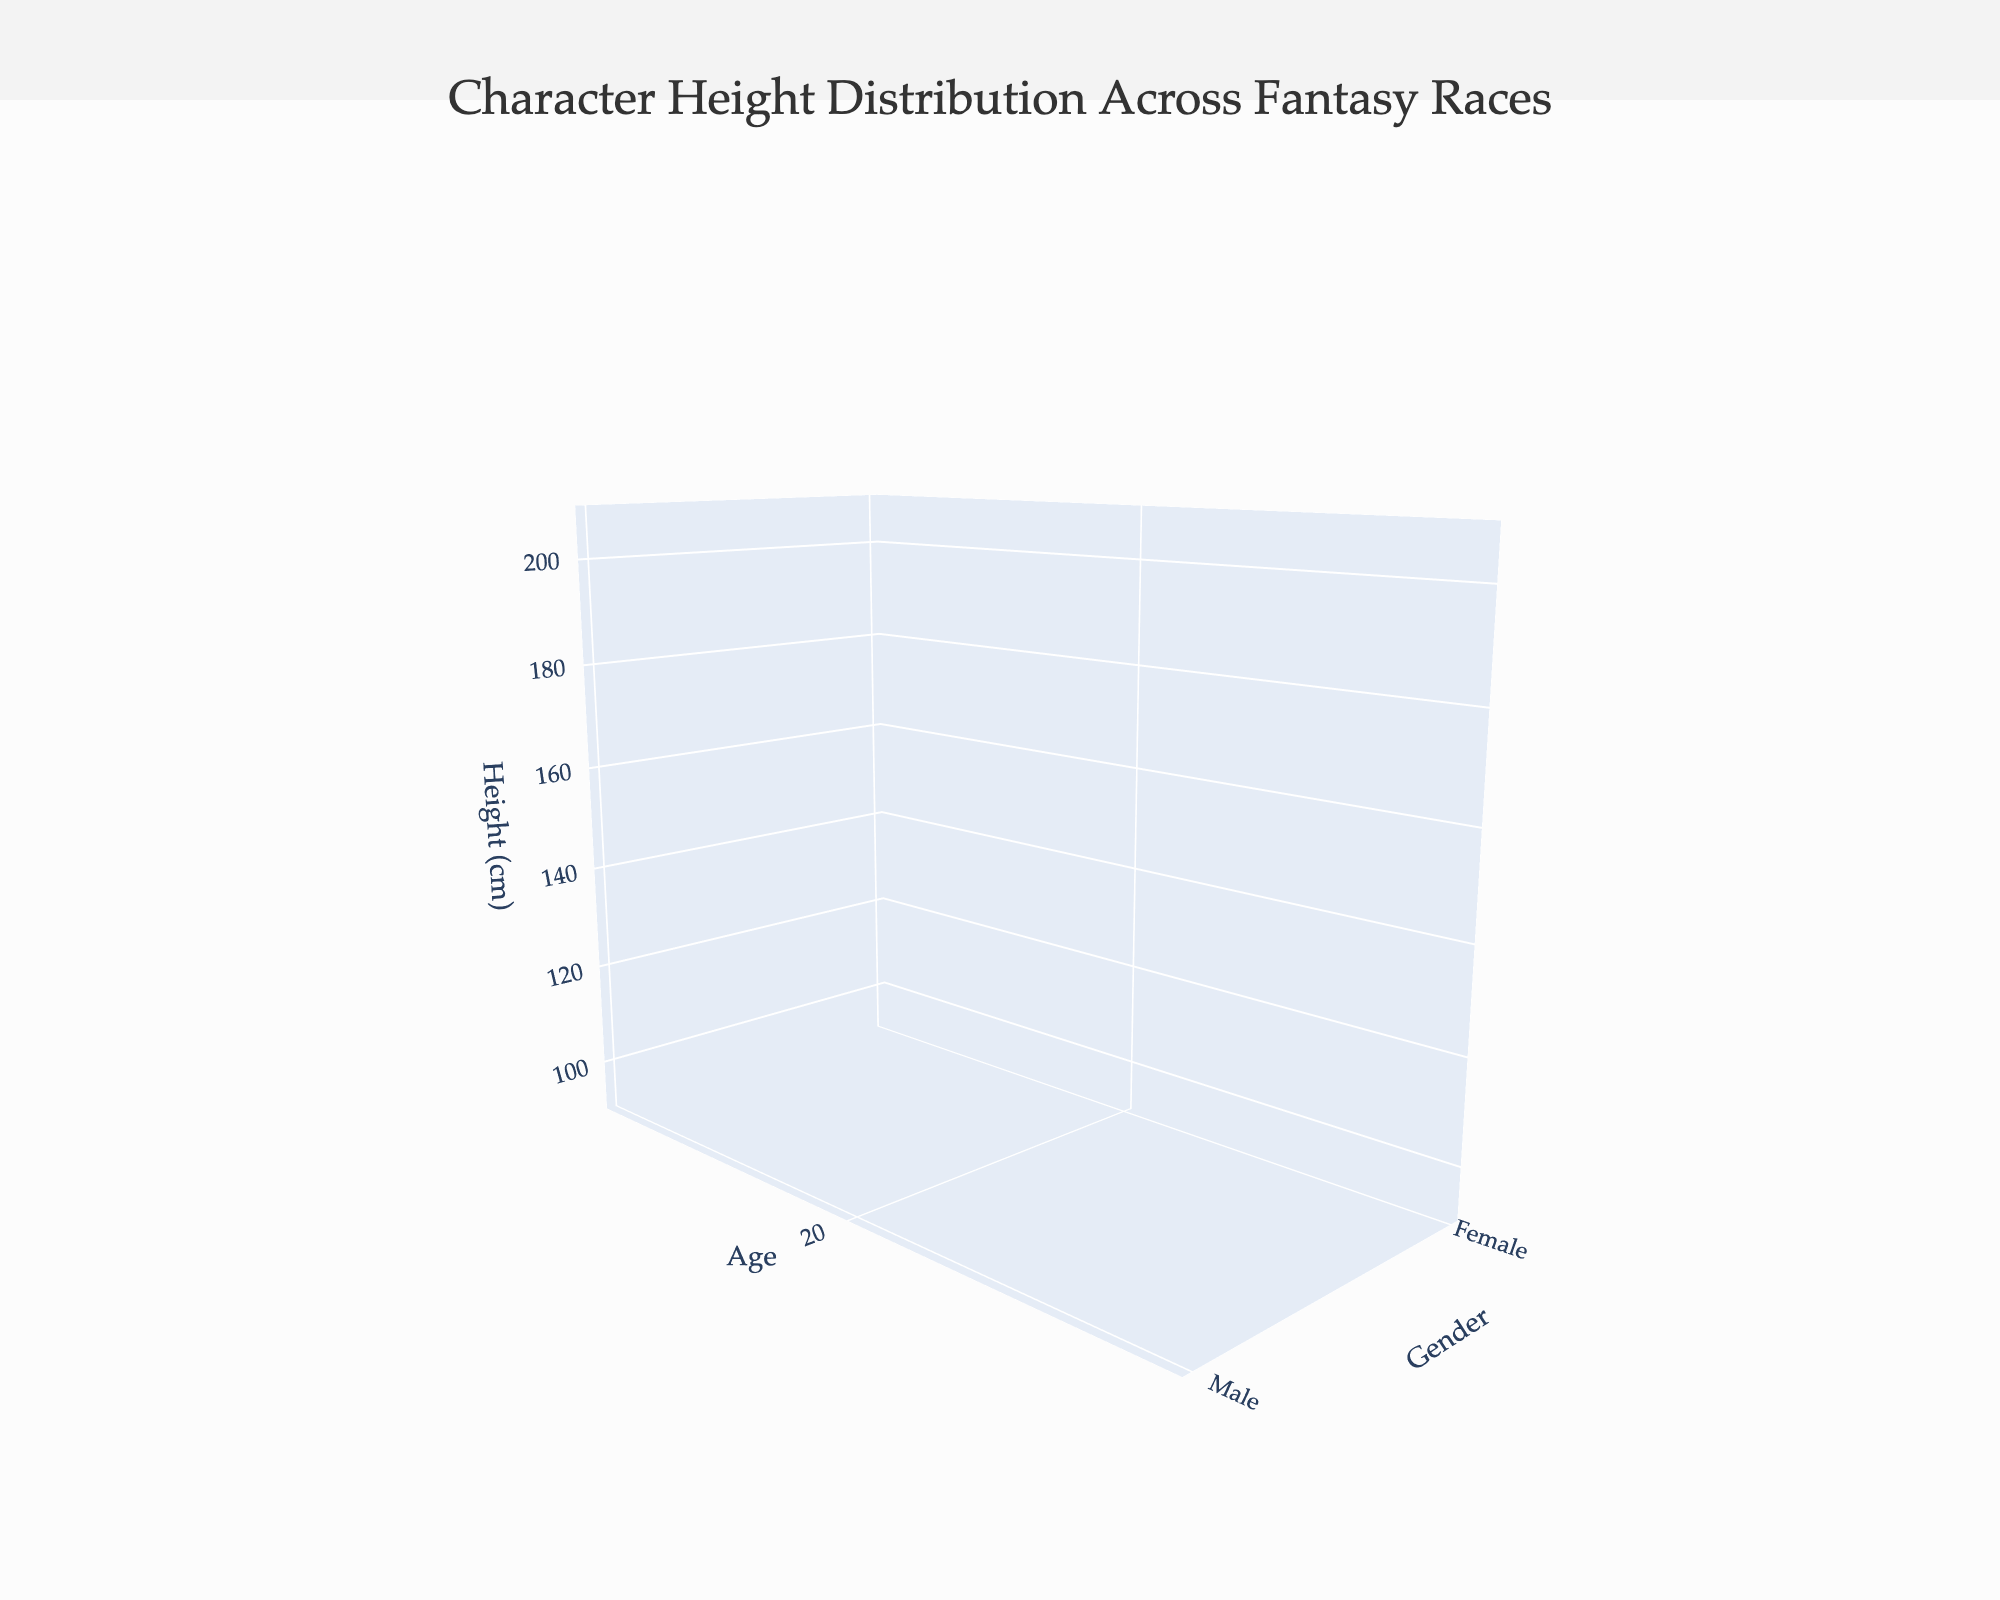What is the title of the figure? The title is usually located at the top of the plot figure. From the description, it is "Character Height Distribution Across Fantasy Races."
Answer: Character Height Distribution Across Fantasy Races Which axis represents age? Age is usually numeric and increasing values should be shown on a major axis. According to the layout, it is indicated as the x-axis.
Answer: X-axis How many unique age groups are present in the figure? The unique age values given in the data set are [20, 40, 60, 80, 100]. Simply count these unique values.
Answer: 5 Which race has the highest average height for males across all ages? To find this, visually assess the z-axis values of each 3D surface plot for males, then calculate the mean height across all ages for each race. The race with the highest average value will be the answer.
Answer: Elf Do males and females of the Elf race converge in height as they age? Look at the Elf surface plots for both males and females. Check if the respective height values (z-axis) for older ages (like 80 and 100) are getting closer to one another.
Answer: Yes Which gender shows the smallest difference in height between the ages of 20 and 100 for Humans? Identify the height values for Human males and females at ages 20 and 100, then compute the difference for both. Compare these differences to find the smallest one.
Answer: Female By how much does the average height of Male Dwarves between ages 20 to 100 increase? Check the height values for Male Dwarves at ages 20 and 100, then compute the difference.
Answer: 12 cm For which race does the height of females continually increase with age? Verify if the height values for all age points (from 20 to 100) for each female race are in increasing order.
Answer: Elf At age 40, how much taller is the average height of Male Orcs compared to Female Halflings? Identify the height of Male Orcs and Female Halflings at age 40 from the z-axis, then calculate the difference.
Answer: 90 cm On average, does the height of Male and Female Human characters increase or decrease with age? Check the height values at multiple age points for both Male and Female Humans and observe the trend. If values are significantly higher in older age groups, it indicates an increase; otherwise, a decrease.
Answer: Increase 